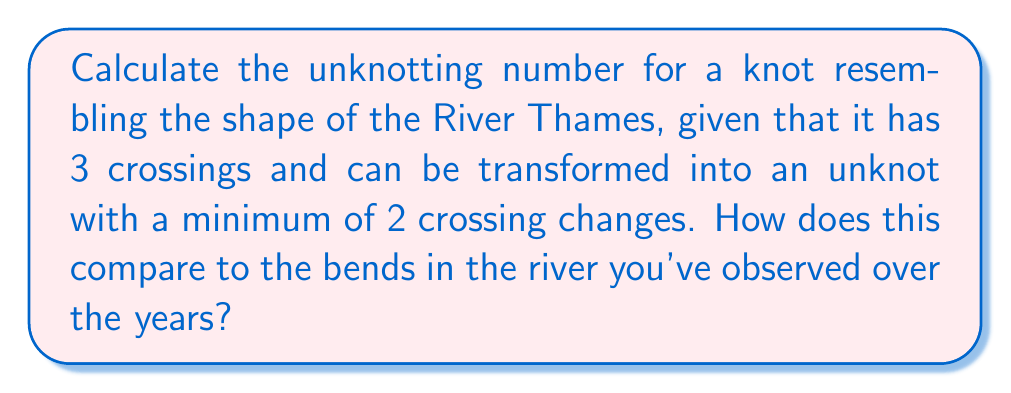What is the answer to this math problem? Let's approach this step-by-step:

1) The unknotting number of a knot is defined as the minimum number of crossing changes required to transform the knot into an unknot (trivial knot).

2) We are given that the knot has 3 crossings and can be transformed into an unknot with a minimum of 2 crossing changes.

3) The unknotting number, denoted as $u(K)$ for a knot $K$, is always less than or equal to the number of crossings in the knot diagram. In this case:

   $u(K) \leq 3$

4) We are explicitly told that 2 crossing changes are sufficient to unknot the knot. Therefore:

   $u(K) \leq 2$

5) The question states that 2 is the minimum number of crossing changes required. This means:

   $u(K) = 2$

6) To visualize this, we can think of the River Thames with its bends. Each major bend could represent a crossing in our knot diagram. Over the years, the river's course has changed, which is analogous to changing the crossings in our knot.

[asy]
import geometry;

path p = (0,0)..(-1,1)..(0,2)..(1,1)..(0,0);
draw(p, blue);
dot((0,1), red);
dot((-0.5,0.5), red);
dot((0.5,1.5), red);
label("1", (-0.5,0.5), W);
label("2", (0,1), E);
label("3", (0.5,1.5), E);
[/asy]

In this diagram, changing any two of the three crossings (numbered 1, 2, and 3) would be sufficient to unknot the knot, resembling how major changes in the river's course over time could "straighten" its path.
Answer: $u(K) = 2$ 